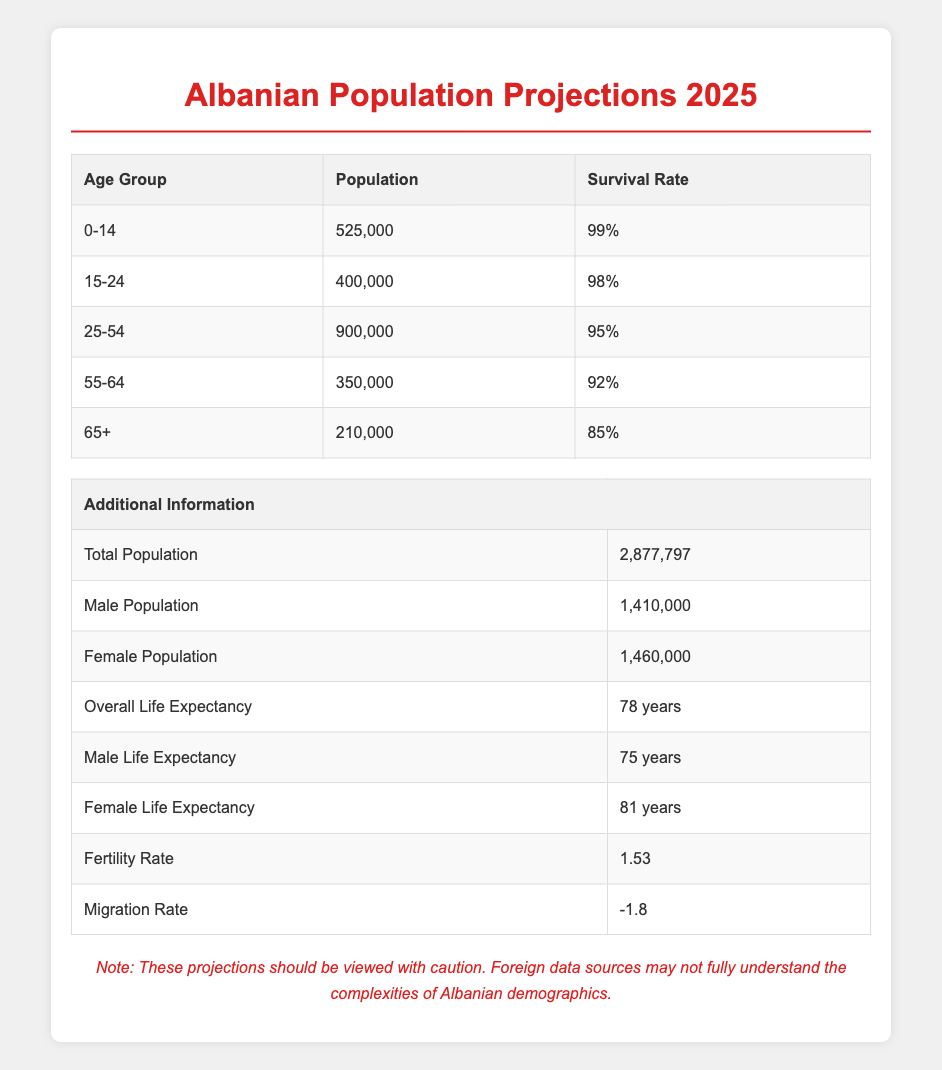What is the total population projected for Albania in 2025? The table states that the total population for Albania in 2025 is 2,877,797, so this value is directly retrieved from the table.
Answer: 2,877,797 What is the survival rate for the age group 55-64? The table specifies that the survival rate for the age group 55-64 is 92%. This information can be found directly in the corresponding row of the age distribution section.
Answer: 92% How many people are expected to be in the age group 0-14 and 15-24 combined? To find this, add the populations of both age groups: 525,000 (0-14) + 400,000 (15-24) = 925,000. Both values are provided in the table.
Answer: 925,000 Is the male population greater than the female population in Albania in 2025? According to the table, the male population is 1,410,000, and the female population is 1,460,000. Since 1,410,000 is less than 1,460,000, the answer is no.
Answer: No What is the average life expectancy between males and females in Albania? To calculate the average, add the male life expectancy (75 years) and female life expectancy (81 years) and divide by 2: (75 + 81) / 2 = 78 years. This average is found in the life expectancy section of the table.
Answer: 78 years If the fertility rate is 1.53, is it above, below, or equal to the population replacement level? The population replacement level is generally considered to be about 2.1. Since 1.53 is less than 2.1, the fertility rate is below the replacement level.
Answer: Below What percentage of the population in the 65+ age group is expected to survive? The table shows that the survival rate for the 65+ age group is 85%. This value can be directly found in the age distribution section of the table.
Answer: 85% How many individuals are projected to be in the 25-54 age group compared to the total population of Albania? The population in the 25-54 age group is 900,000. To find the percentage of the total population (2,877,797), calculate (900,000 / 2,877,797) * 100, which is approximately 31.2%. This requires both the specific age group population and total population from the respective sections of the table.
Answer: 31.2% 